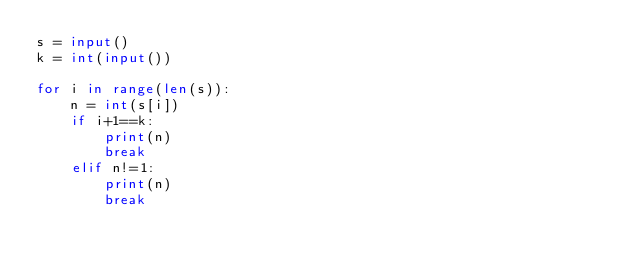<code> <loc_0><loc_0><loc_500><loc_500><_Python_>s = input()
k = int(input())

for i in range(len(s)):
    n = int(s[i])
    if i+1==k:
        print(n)
        break
    elif n!=1:
        print(n)
        break </code> 